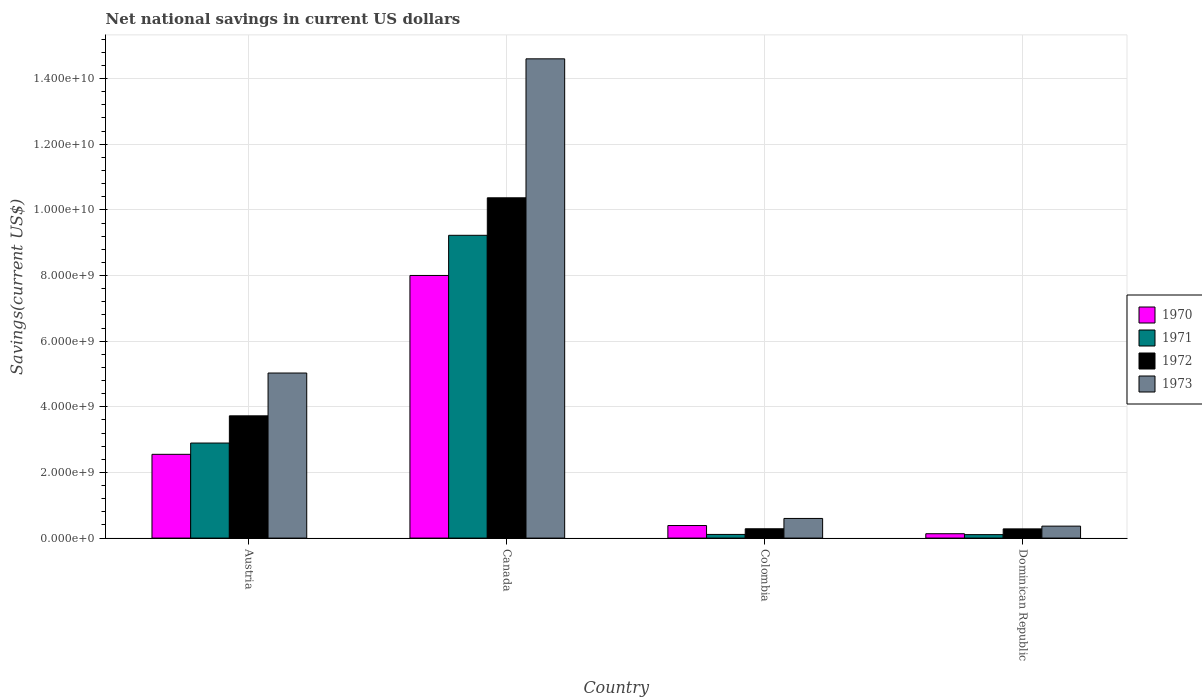How many different coloured bars are there?
Your response must be concise. 4. Are the number of bars on each tick of the X-axis equal?
Your response must be concise. Yes. How many bars are there on the 3rd tick from the right?
Give a very brief answer. 4. In how many cases, is the number of bars for a given country not equal to the number of legend labels?
Keep it short and to the point. 0. What is the net national savings in 1970 in Colombia?
Provide a short and direct response. 3.83e+08. Across all countries, what is the maximum net national savings in 1970?
Your answer should be very brief. 8.00e+09. Across all countries, what is the minimum net national savings in 1972?
Provide a short and direct response. 2.80e+08. In which country was the net national savings in 1971 maximum?
Keep it short and to the point. Canada. In which country was the net national savings in 1970 minimum?
Give a very brief answer. Dominican Republic. What is the total net national savings in 1973 in the graph?
Your answer should be very brief. 2.06e+1. What is the difference between the net national savings in 1972 in Austria and that in Dominican Republic?
Keep it short and to the point. 3.44e+09. What is the difference between the net national savings in 1973 in Canada and the net national savings in 1971 in Dominican Republic?
Offer a terse response. 1.45e+1. What is the average net national savings in 1973 per country?
Keep it short and to the point. 5.15e+09. What is the difference between the net national savings of/in 1972 and net national savings of/in 1973 in Austria?
Provide a short and direct response. -1.30e+09. What is the ratio of the net national savings in 1971 in Colombia to that in Dominican Republic?
Provide a succinct answer. 1.06. Is the net national savings in 1971 in Austria less than that in Colombia?
Offer a very short reply. No. What is the difference between the highest and the second highest net national savings in 1972?
Your response must be concise. 3.44e+09. What is the difference between the highest and the lowest net national savings in 1970?
Offer a terse response. 7.87e+09. In how many countries, is the net national savings in 1973 greater than the average net national savings in 1973 taken over all countries?
Give a very brief answer. 1. Is the sum of the net national savings in 1972 in Austria and Dominican Republic greater than the maximum net national savings in 1971 across all countries?
Offer a terse response. No. What does the 1st bar from the left in Austria represents?
Your response must be concise. 1970. What does the 4th bar from the right in Austria represents?
Your answer should be very brief. 1970. How many bars are there?
Offer a terse response. 16. How many countries are there in the graph?
Provide a short and direct response. 4. Are the values on the major ticks of Y-axis written in scientific E-notation?
Ensure brevity in your answer.  Yes. Does the graph contain any zero values?
Make the answer very short. No. What is the title of the graph?
Offer a very short reply. Net national savings in current US dollars. What is the label or title of the X-axis?
Ensure brevity in your answer.  Country. What is the label or title of the Y-axis?
Ensure brevity in your answer.  Savings(current US$). What is the Savings(current US$) in 1970 in Austria?
Give a very brief answer. 2.55e+09. What is the Savings(current US$) in 1971 in Austria?
Your response must be concise. 2.90e+09. What is the Savings(current US$) of 1972 in Austria?
Your answer should be very brief. 3.73e+09. What is the Savings(current US$) of 1973 in Austria?
Offer a very short reply. 5.03e+09. What is the Savings(current US$) in 1970 in Canada?
Provide a short and direct response. 8.00e+09. What is the Savings(current US$) in 1971 in Canada?
Provide a succinct answer. 9.23e+09. What is the Savings(current US$) of 1972 in Canada?
Make the answer very short. 1.04e+1. What is the Savings(current US$) in 1973 in Canada?
Provide a short and direct response. 1.46e+1. What is the Savings(current US$) in 1970 in Colombia?
Make the answer very short. 3.83e+08. What is the Savings(current US$) in 1971 in Colombia?
Provide a short and direct response. 1.11e+08. What is the Savings(current US$) of 1972 in Colombia?
Offer a very short reply. 2.84e+08. What is the Savings(current US$) in 1973 in Colombia?
Your answer should be very brief. 5.98e+08. What is the Savings(current US$) of 1970 in Dominican Republic?
Offer a terse response. 1.33e+08. What is the Savings(current US$) in 1971 in Dominican Republic?
Make the answer very short. 1.05e+08. What is the Savings(current US$) in 1972 in Dominican Republic?
Your response must be concise. 2.80e+08. What is the Savings(current US$) in 1973 in Dominican Republic?
Provide a short and direct response. 3.65e+08. Across all countries, what is the maximum Savings(current US$) in 1970?
Ensure brevity in your answer.  8.00e+09. Across all countries, what is the maximum Savings(current US$) of 1971?
Your answer should be compact. 9.23e+09. Across all countries, what is the maximum Savings(current US$) of 1972?
Your answer should be compact. 1.04e+1. Across all countries, what is the maximum Savings(current US$) of 1973?
Offer a very short reply. 1.46e+1. Across all countries, what is the minimum Savings(current US$) in 1970?
Your answer should be very brief. 1.33e+08. Across all countries, what is the minimum Savings(current US$) in 1971?
Provide a short and direct response. 1.05e+08. Across all countries, what is the minimum Savings(current US$) in 1972?
Keep it short and to the point. 2.80e+08. Across all countries, what is the minimum Savings(current US$) in 1973?
Your response must be concise. 3.65e+08. What is the total Savings(current US$) in 1970 in the graph?
Offer a very short reply. 1.11e+1. What is the total Savings(current US$) in 1971 in the graph?
Make the answer very short. 1.23e+1. What is the total Savings(current US$) of 1972 in the graph?
Your answer should be very brief. 1.47e+1. What is the total Savings(current US$) of 1973 in the graph?
Give a very brief answer. 2.06e+1. What is the difference between the Savings(current US$) in 1970 in Austria and that in Canada?
Your answer should be compact. -5.45e+09. What is the difference between the Savings(current US$) in 1971 in Austria and that in Canada?
Your answer should be compact. -6.33e+09. What is the difference between the Savings(current US$) in 1972 in Austria and that in Canada?
Your response must be concise. -6.64e+09. What is the difference between the Savings(current US$) of 1973 in Austria and that in Canada?
Offer a terse response. -9.57e+09. What is the difference between the Savings(current US$) of 1970 in Austria and that in Colombia?
Your answer should be very brief. 2.17e+09. What is the difference between the Savings(current US$) of 1971 in Austria and that in Colombia?
Ensure brevity in your answer.  2.78e+09. What is the difference between the Savings(current US$) of 1972 in Austria and that in Colombia?
Your answer should be compact. 3.44e+09. What is the difference between the Savings(current US$) in 1973 in Austria and that in Colombia?
Your answer should be very brief. 4.43e+09. What is the difference between the Savings(current US$) of 1970 in Austria and that in Dominican Republic?
Make the answer very short. 2.42e+09. What is the difference between the Savings(current US$) of 1971 in Austria and that in Dominican Republic?
Keep it short and to the point. 2.79e+09. What is the difference between the Savings(current US$) of 1972 in Austria and that in Dominican Republic?
Your answer should be very brief. 3.44e+09. What is the difference between the Savings(current US$) of 1973 in Austria and that in Dominican Republic?
Give a very brief answer. 4.66e+09. What is the difference between the Savings(current US$) in 1970 in Canada and that in Colombia?
Your response must be concise. 7.62e+09. What is the difference between the Savings(current US$) of 1971 in Canada and that in Colombia?
Make the answer very short. 9.11e+09. What is the difference between the Savings(current US$) in 1972 in Canada and that in Colombia?
Make the answer very short. 1.01e+1. What is the difference between the Savings(current US$) of 1973 in Canada and that in Colombia?
Provide a short and direct response. 1.40e+1. What is the difference between the Savings(current US$) of 1970 in Canada and that in Dominican Republic?
Keep it short and to the point. 7.87e+09. What is the difference between the Savings(current US$) in 1971 in Canada and that in Dominican Republic?
Provide a short and direct response. 9.12e+09. What is the difference between the Savings(current US$) of 1972 in Canada and that in Dominican Republic?
Your response must be concise. 1.01e+1. What is the difference between the Savings(current US$) of 1973 in Canada and that in Dominican Republic?
Offer a terse response. 1.42e+1. What is the difference between the Savings(current US$) of 1970 in Colombia and that in Dominican Republic?
Provide a succinct answer. 2.50e+08. What is the difference between the Savings(current US$) in 1971 in Colombia and that in Dominican Republic?
Keep it short and to the point. 6.03e+06. What is the difference between the Savings(current US$) of 1972 in Colombia and that in Dominican Republic?
Your response must be concise. 3.48e+06. What is the difference between the Savings(current US$) in 1973 in Colombia and that in Dominican Republic?
Make the answer very short. 2.34e+08. What is the difference between the Savings(current US$) of 1970 in Austria and the Savings(current US$) of 1971 in Canada?
Offer a very short reply. -6.67e+09. What is the difference between the Savings(current US$) in 1970 in Austria and the Savings(current US$) in 1972 in Canada?
Your answer should be very brief. -7.82e+09. What is the difference between the Savings(current US$) in 1970 in Austria and the Savings(current US$) in 1973 in Canada?
Offer a terse response. -1.20e+1. What is the difference between the Savings(current US$) in 1971 in Austria and the Savings(current US$) in 1972 in Canada?
Offer a terse response. -7.47e+09. What is the difference between the Savings(current US$) in 1971 in Austria and the Savings(current US$) in 1973 in Canada?
Give a very brief answer. -1.17e+1. What is the difference between the Savings(current US$) in 1972 in Austria and the Savings(current US$) in 1973 in Canada?
Make the answer very short. -1.09e+1. What is the difference between the Savings(current US$) of 1970 in Austria and the Savings(current US$) of 1971 in Colombia?
Your response must be concise. 2.44e+09. What is the difference between the Savings(current US$) in 1970 in Austria and the Savings(current US$) in 1972 in Colombia?
Your response must be concise. 2.27e+09. What is the difference between the Savings(current US$) in 1970 in Austria and the Savings(current US$) in 1973 in Colombia?
Give a very brief answer. 1.95e+09. What is the difference between the Savings(current US$) of 1971 in Austria and the Savings(current US$) of 1972 in Colombia?
Your answer should be compact. 2.61e+09. What is the difference between the Savings(current US$) of 1971 in Austria and the Savings(current US$) of 1973 in Colombia?
Offer a very short reply. 2.30e+09. What is the difference between the Savings(current US$) in 1972 in Austria and the Savings(current US$) in 1973 in Colombia?
Your response must be concise. 3.13e+09. What is the difference between the Savings(current US$) in 1970 in Austria and the Savings(current US$) in 1971 in Dominican Republic?
Offer a very short reply. 2.45e+09. What is the difference between the Savings(current US$) in 1970 in Austria and the Savings(current US$) in 1972 in Dominican Republic?
Your response must be concise. 2.27e+09. What is the difference between the Savings(current US$) in 1970 in Austria and the Savings(current US$) in 1973 in Dominican Republic?
Keep it short and to the point. 2.19e+09. What is the difference between the Savings(current US$) of 1971 in Austria and the Savings(current US$) of 1972 in Dominican Republic?
Provide a succinct answer. 2.62e+09. What is the difference between the Savings(current US$) in 1971 in Austria and the Savings(current US$) in 1973 in Dominican Republic?
Your answer should be compact. 2.53e+09. What is the difference between the Savings(current US$) of 1972 in Austria and the Savings(current US$) of 1973 in Dominican Republic?
Provide a short and direct response. 3.36e+09. What is the difference between the Savings(current US$) of 1970 in Canada and the Savings(current US$) of 1971 in Colombia?
Your answer should be compact. 7.89e+09. What is the difference between the Savings(current US$) in 1970 in Canada and the Savings(current US$) in 1972 in Colombia?
Ensure brevity in your answer.  7.72e+09. What is the difference between the Savings(current US$) in 1970 in Canada and the Savings(current US$) in 1973 in Colombia?
Provide a short and direct response. 7.40e+09. What is the difference between the Savings(current US$) of 1971 in Canada and the Savings(current US$) of 1972 in Colombia?
Your answer should be compact. 8.94e+09. What is the difference between the Savings(current US$) of 1971 in Canada and the Savings(current US$) of 1973 in Colombia?
Offer a terse response. 8.63e+09. What is the difference between the Savings(current US$) in 1972 in Canada and the Savings(current US$) in 1973 in Colombia?
Keep it short and to the point. 9.77e+09. What is the difference between the Savings(current US$) in 1970 in Canada and the Savings(current US$) in 1971 in Dominican Republic?
Make the answer very short. 7.90e+09. What is the difference between the Savings(current US$) of 1970 in Canada and the Savings(current US$) of 1972 in Dominican Republic?
Offer a very short reply. 7.72e+09. What is the difference between the Savings(current US$) of 1970 in Canada and the Savings(current US$) of 1973 in Dominican Republic?
Your answer should be very brief. 7.64e+09. What is the difference between the Savings(current US$) in 1971 in Canada and the Savings(current US$) in 1972 in Dominican Republic?
Offer a terse response. 8.94e+09. What is the difference between the Savings(current US$) in 1971 in Canada and the Savings(current US$) in 1973 in Dominican Republic?
Offer a very short reply. 8.86e+09. What is the difference between the Savings(current US$) in 1972 in Canada and the Savings(current US$) in 1973 in Dominican Republic?
Provide a succinct answer. 1.00e+1. What is the difference between the Savings(current US$) of 1970 in Colombia and the Savings(current US$) of 1971 in Dominican Republic?
Keep it short and to the point. 2.77e+08. What is the difference between the Savings(current US$) in 1970 in Colombia and the Savings(current US$) in 1972 in Dominican Republic?
Keep it short and to the point. 1.02e+08. What is the difference between the Savings(current US$) in 1970 in Colombia and the Savings(current US$) in 1973 in Dominican Republic?
Offer a terse response. 1.82e+07. What is the difference between the Savings(current US$) in 1971 in Colombia and the Savings(current US$) in 1972 in Dominican Republic?
Ensure brevity in your answer.  -1.69e+08. What is the difference between the Savings(current US$) in 1971 in Colombia and the Savings(current US$) in 1973 in Dominican Republic?
Ensure brevity in your answer.  -2.53e+08. What is the difference between the Savings(current US$) of 1972 in Colombia and the Savings(current US$) of 1973 in Dominican Republic?
Give a very brief answer. -8.05e+07. What is the average Savings(current US$) in 1970 per country?
Your answer should be compact. 2.77e+09. What is the average Savings(current US$) of 1971 per country?
Give a very brief answer. 3.08e+09. What is the average Savings(current US$) in 1972 per country?
Offer a very short reply. 3.66e+09. What is the average Savings(current US$) of 1973 per country?
Your response must be concise. 5.15e+09. What is the difference between the Savings(current US$) in 1970 and Savings(current US$) in 1971 in Austria?
Your response must be concise. -3.44e+08. What is the difference between the Savings(current US$) in 1970 and Savings(current US$) in 1972 in Austria?
Keep it short and to the point. -1.17e+09. What is the difference between the Savings(current US$) in 1970 and Savings(current US$) in 1973 in Austria?
Your answer should be compact. -2.48e+09. What is the difference between the Savings(current US$) of 1971 and Savings(current US$) of 1972 in Austria?
Ensure brevity in your answer.  -8.29e+08. What is the difference between the Savings(current US$) in 1971 and Savings(current US$) in 1973 in Austria?
Provide a short and direct response. -2.13e+09. What is the difference between the Savings(current US$) of 1972 and Savings(current US$) of 1973 in Austria?
Make the answer very short. -1.30e+09. What is the difference between the Savings(current US$) of 1970 and Savings(current US$) of 1971 in Canada?
Give a very brief answer. -1.22e+09. What is the difference between the Savings(current US$) of 1970 and Savings(current US$) of 1972 in Canada?
Offer a very short reply. -2.37e+09. What is the difference between the Savings(current US$) of 1970 and Savings(current US$) of 1973 in Canada?
Your answer should be compact. -6.60e+09. What is the difference between the Savings(current US$) of 1971 and Savings(current US$) of 1972 in Canada?
Make the answer very short. -1.14e+09. What is the difference between the Savings(current US$) in 1971 and Savings(current US$) in 1973 in Canada?
Keep it short and to the point. -5.38e+09. What is the difference between the Savings(current US$) of 1972 and Savings(current US$) of 1973 in Canada?
Give a very brief answer. -4.23e+09. What is the difference between the Savings(current US$) in 1970 and Savings(current US$) in 1971 in Colombia?
Make the answer very short. 2.71e+08. What is the difference between the Savings(current US$) in 1970 and Savings(current US$) in 1972 in Colombia?
Your response must be concise. 9.87e+07. What is the difference between the Savings(current US$) of 1970 and Savings(current US$) of 1973 in Colombia?
Keep it short and to the point. -2.16e+08. What is the difference between the Savings(current US$) of 1971 and Savings(current US$) of 1972 in Colombia?
Ensure brevity in your answer.  -1.73e+08. What is the difference between the Savings(current US$) in 1971 and Savings(current US$) in 1973 in Colombia?
Provide a short and direct response. -4.87e+08. What is the difference between the Savings(current US$) in 1972 and Savings(current US$) in 1973 in Colombia?
Make the answer very short. -3.14e+08. What is the difference between the Savings(current US$) of 1970 and Savings(current US$) of 1971 in Dominican Republic?
Give a very brief answer. 2.74e+07. What is the difference between the Savings(current US$) of 1970 and Savings(current US$) of 1972 in Dominican Republic?
Provide a succinct answer. -1.48e+08. What is the difference between the Savings(current US$) in 1970 and Savings(current US$) in 1973 in Dominican Republic?
Keep it short and to the point. -2.32e+08. What is the difference between the Savings(current US$) in 1971 and Savings(current US$) in 1972 in Dominican Republic?
Offer a terse response. -1.75e+08. What is the difference between the Savings(current US$) of 1971 and Savings(current US$) of 1973 in Dominican Republic?
Make the answer very short. -2.59e+08. What is the difference between the Savings(current US$) of 1972 and Savings(current US$) of 1973 in Dominican Republic?
Your response must be concise. -8.40e+07. What is the ratio of the Savings(current US$) of 1970 in Austria to that in Canada?
Your answer should be very brief. 0.32. What is the ratio of the Savings(current US$) of 1971 in Austria to that in Canada?
Provide a short and direct response. 0.31. What is the ratio of the Savings(current US$) of 1972 in Austria to that in Canada?
Keep it short and to the point. 0.36. What is the ratio of the Savings(current US$) in 1973 in Austria to that in Canada?
Keep it short and to the point. 0.34. What is the ratio of the Savings(current US$) in 1970 in Austria to that in Colombia?
Your response must be concise. 6.67. What is the ratio of the Savings(current US$) of 1971 in Austria to that in Colombia?
Keep it short and to the point. 25.99. What is the ratio of the Savings(current US$) in 1972 in Austria to that in Colombia?
Your answer should be compact. 13.12. What is the ratio of the Savings(current US$) in 1973 in Austria to that in Colombia?
Keep it short and to the point. 8.4. What is the ratio of the Savings(current US$) in 1970 in Austria to that in Dominican Republic?
Provide a short and direct response. 19.23. What is the ratio of the Savings(current US$) of 1971 in Austria to that in Dominican Republic?
Offer a terse response. 27.48. What is the ratio of the Savings(current US$) of 1972 in Austria to that in Dominican Republic?
Offer a terse response. 13.28. What is the ratio of the Savings(current US$) of 1973 in Austria to that in Dominican Republic?
Offer a terse response. 13.8. What is the ratio of the Savings(current US$) in 1970 in Canada to that in Colombia?
Your response must be concise. 20.91. What is the ratio of the Savings(current US$) of 1971 in Canada to that in Colombia?
Ensure brevity in your answer.  82.79. What is the ratio of the Savings(current US$) in 1972 in Canada to that in Colombia?
Offer a very short reply. 36.51. What is the ratio of the Savings(current US$) of 1973 in Canada to that in Colombia?
Provide a succinct answer. 24.4. What is the ratio of the Savings(current US$) in 1970 in Canada to that in Dominican Republic?
Offer a very short reply. 60.27. What is the ratio of the Savings(current US$) in 1971 in Canada to that in Dominican Republic?
Offer a very short reply. 87.52. What is the ratio of the Savings(current US$) of 1972 in Canada to that in Dominican Republic?
Make the answer very short. 36.96. What is the ratio of the Savings(current US$) in 1973 in Canada to that in Dominican Republic?
Make the answer very short. 40.06. What is the ratio of the Savings(current US$) of 1970 in Colombia to that in Dominican Republic?
Your answer should be compact. 2.88. What is the ratio of the Savings(current US$) in 1971 in Colombia to that in Dominican Republic?
Offer a very short reply. 1.06. What is the ratio of the Savings(current US$) of 1972 in Colombia to that in Dominican Republic?
Your answer should be compact. 1.01. What is the ratio of the Savings(current US$) of 1973 in Colombia to that in Dominican Republic?
Provide a short and direct response. 1.64. What is the difference between the highest and the second highest Savings(current US$) of 1970?
Your answer should be compact. 5.45e+09. What is the difference between the highest and the second highest Savings(current US$) of 1971?
Your response must be concise. 6.33e+09. What is the difference between the highest and the second highest Savings(current US$) in 1972?
Provide a short and direct response. 6.64e+09. What is the difference between the highest and the second highest Savings(current US$) of 1973?
Your response must be concise. 9.57e+09. What is the difference between the highest and the lowest Savings(current US$) of 1970?
Provide a short and direct response. 7.87e+09. What is the difference between the highest and the lowest Savings(current US$) in 1971?
Make the answer very short. 9.12e+09. What is the difference between the highest and the lowest Savings(current US$) in 1972?
Offer a terse response. 1.01e+1. What is the difference between the highest and the lowest Savings(current US$) of 1973?
Provide a succinct answer. 1.42e+1. 